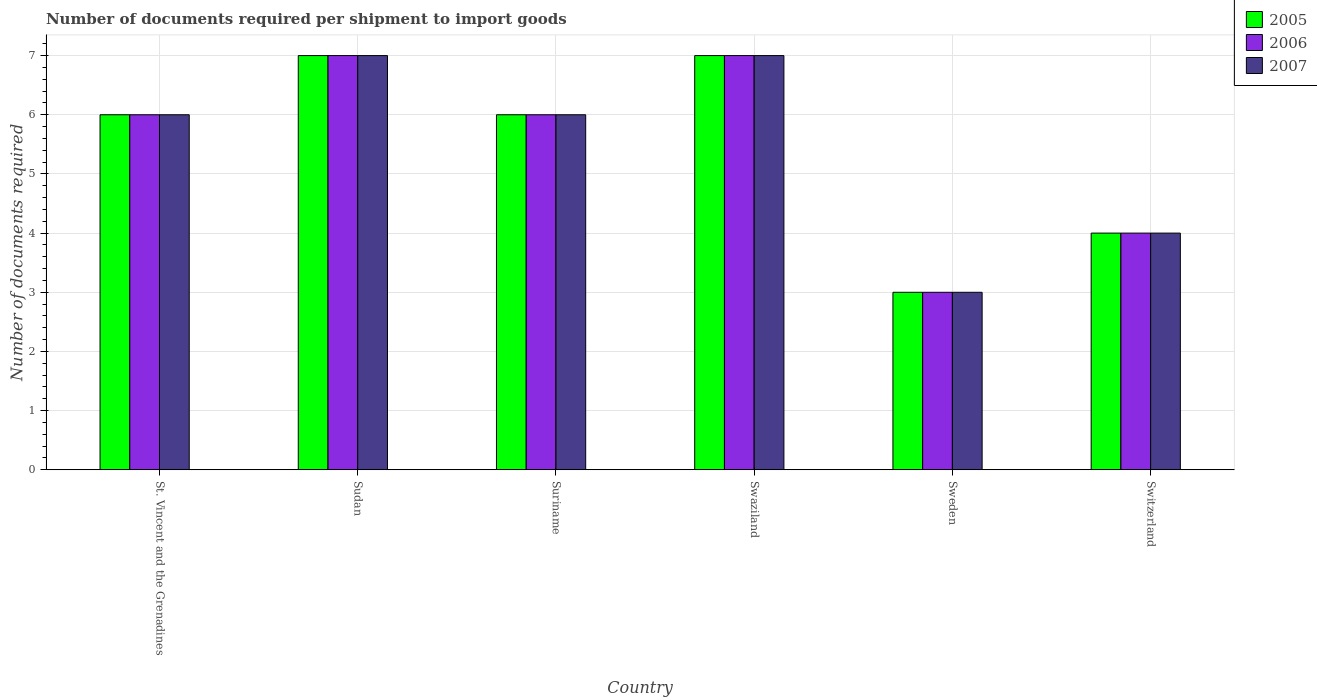Are the number of bars on each tick of the X-axis equal?
Keep it short and to the point. Yes. What is the label of the 4th group of bars from the left?
Keep it short and to the point. Swaziland. Across all countries, what is the maximum number of documents required per shipment to import goods in 2005?
Provide a succinct answer. 7. In which country was the number of documents required per shipment to import goods in 2006 maximum?
Provide a short and direct response. Sudan. What is the total number of documents required per shipment to import goods in 2006 in the graph?
Make the answer very short. 33. What is the difference between the number of documents required per shipment to import goods in 2006 in Switzerland and the number of documents required per shipment to import goods in 2007 in Swaziland?
Offer a terse response. -3. What is the difference between the number of documents required per shipment to import goods of/in 2005 and number of documents required per shipment to import goods of/in 2006 in Swaziland?
Your response must be concise. 0. In how many countries, is the number of documents required per shipment to import goods in 2007 greater than 5.2?
Offer a terse response. 4. What is the ratio of the number of documents required per shipment to import goods in 2007 in Sudan to that in Suriname?
Make the answer very short. 1.17. Is the number of documents required per shipment to import goods in 2006 in St. Vincent and the Grenadines less than that in Swaziland?
Offer a very short reply. Yes. Is the difference between the number of documents required per shipment to import goods in 2005 in Sudan and Suriname greater than the difference between the number of documents required per shipment to import goods in 2006 in Sudan and Suriname?
Your answer should be compact. No. What is the difference between the highest and the second highest number of documents required per shipment to import goods in 2005?
Offer a terse response. -1. In how many countries, is the number of documents required per shipment to import goods in 2007 greater than the average number of documents required per shipment to import goods in 2007 taken over all countries?
Offer a very short reply. 4. How many bars are there?
Make the answer very short. 18. Does the graph contain any zero values?
Give a very brief answer. No. Where does the legend appear in the graph?
Your answer should be compact. Top right. How many legend labels are there?
Ensure brevity in your answer.  3. How are the legend labels stacked?
Make the answer very short. Vertical. What is the title of the graph?
Ensure brevity in your answer.  Number of documents required per shipment to import goods. Does "2007" appear as one of the legend labels in the graph?
Ensure brevity in your answer.  Yes. What is the label or title of the Y-axis?
Your response must be concise. Number of documents required. What is the Number of documents required of 2006 in St. Vincent and the Grenadines?
Give a very brief answer. 6. What is the Number of documents required in 2005 in Sudan?
Offer a very short reply. 7. What is the Number of documents required in 2007 in Sudan?
Offer a very short reply. 7. What is the Number of documents required in 2005 in Suriname?
Your answer should be very brief. 6. What is the Number of documents required of 2006 in Suriname?
Your answer should be very brief. 6. What is the Number of documents required of 2006 in Swaziland?
Provide a short and direct response. 7. What is the Number of documents required of 2007 in Swaziland?
Your answer should be very brief. 7. What is the Number of documents required in 2007 in Switzerland?
Make the answer very short. 4. Across all countries, what is the minimum Number of documents required in 2005?
Make the answer very short. 3. Across all countries, what is the minimum Number of documents required in 2007?
Provide a succinct answer. 3. What is the total Number of documents required of 2006 in the graph?
Provide a succinct answer. 33. What is the difference between the Number of documents required of 2005 in St. Vincent and the Grenadines and that in Sudan?
Ensure brevity in your answer.  -1. What is the difference between the Number of documents required in 2005 in St. Vincent and the Grenadines and that in Suriname?
Your answer should be very brief. 0. What is the difference between the Number of documents required in 2006 in St. Vincent and the Grenadines and that in Suriname?
Offer a very short reply. 0. What is the difference between the Number of documents required in 2005 in St. Vincent and the Grenadines and that in Swaziland?
Offer a very short reply. -1. What is the difference between the Number of documents required in 2005 in St. Vincent and the Grenadines and that in Sweden?
Offer a very short reply. 3. What is the difference between the Number of documents required of 2006 in St. Vincent and the Grenadines and that in Switzerland?
Give a very brief answer. 2. What is the difference between the Number of documents required of 2006 in Sudan and that in Suriname?
Offer a terse response. 1. What is the difference between the Number of documents required of 2007 in Sudan and that in Suriname?
Offer a terse response. 1. What is the difference between the Number of documents required in 2005 in Sudan and that in Swaziland?
Give a very brief answer. 0. What is the difference between the Number of documents required in 2005 in Sudan and that in Sweden?
Provide a succinct answer. 4. What is the difference between the Number of documents required in 2007 in Sudan and that in Sweden?
Provide a succinct answer. 4. What is the difference between the Number of documents required of 2005 in Sudan and that in Switzerland?
Offer a very short reply. 3. What is the difference between the Number of documents required of 2005 in Suriname and that in Swaziland?
Ensure brevity in your answer.  -1. What is the difference between the Number of documents required in 2005 in Suriname and that in Sweden?
Offer a terse response. 3. What is the difference between the Number of documents required of 2005 in Suriname and that in Switzerland?
Keep it short and to the point. 2. What is the difference between the Number of documents required of 2007 in Swaziland and that in Sweden?
Your response must be concise. 4. What is the difference between the Number of documents required in 2005 in Sweden and that in Switzerland?
Your answer should be very brief. -1. What is the difference between the Number of documents required of 2006 in Sweden and that in Switzerland?
Your response must be concise. -1. What is the difference between the Number of documents required in 2007 in Sweden and that in Switzerland?
Your answer should be very brief. -1. What is the difference between the Number of documents required in 2005 in St. Vincent and the Grenadines and the Number of documents required in 2006 in Sudan?
Provide a short and direct response. -1. What is the difference between the Number of documents required in 2005 in St. Vincent and the Grenadines and the Number of documents required in 2007 in Sudan?
Offer a very short reply. -1. What is the difference between the Number of documents required of 2005 in St. Vincent and the Grenadines and the Number of documents required of 2006 in Suriname?
Your answer should be compact. 0. What is the difference between the Number of documents required of 2005 in St. Vincent and the Grenadines and the Number of documents required of 2007 in Swaziland?
Your answer should be very brief. -1. What is the difference between the Number of documents required of 2005 in St. Vincent and the Grenadines and the Number of documents required of 2006 in Sweden?
Make the answer very short. 3. What is the difference between the Number of documents required in 2005 in St. Vincent and the Grenadines and the Number of documents required in 2007 in Sweden?
Keep it short and to the point. 3. What is the difference between the Number of documents required in 2005 in St. Vincent and the Grenadines and the Number of documents required in 2006 in Switzerland?
Ensure brevity in your answer.  2. What is the difference between the Number of documents required in 2005 in Sudan and the Number of documents required in 2006 in Suriname?
Provide a succinct answer. 1. What is the difference between the Number of documents required of 2005 in Sudan and the Number of documents required of 2007 in Suriname?
Your response must be concise. 1. What is the difference between the Number of documents required in 2005 in Sudan and the Number of documents required in 2006 in Swaziland?
Give a very brief answer. 0. What is the difference between the Number of documents required of 2006 in Sudan and the Number of documents required of 2007 in Swaziland?
Offer a very short reply. 0. What is the difference between the Number of documents required in 2005 in Sudan and the Number of documents required in 2006 in Sweden?
Offer a very short reply. 4. What is the difference between the Number of documents required of 2005 in Sudan and the Number of documents required of 2007 in Switzerland?
Provide a short and direct response. 3. What is the difference between the Number of documents required in 2006 in Sudan and the Number of documents required in 2007 in Switzerland?
Make the answer very short. 3. What is the difference between the Number of documents required of 2005 in Suriname and the Number of documents required of 2006 in Swaziland?
Your answer should be very brief. -1. What is the difference between the Number of documents required of 2005 in Suriname and the Number of documents required of 2007 in Swaziland?
Your response must be concise. -1. What is the difference between the Number of documents required in 2006 in Suriname and the Number of documents required in 2007 in Swaziland?
Keep it short and to the point. -1. What is the difference between the Number of documents required in 2005 in Suriname and the Number of documents required in 2006 in Sweden?
Provide a succinct answer. 3. What is the difference between the Number of documents required of 2006 in Suriname and the Number of documents required of 2007 in Sweden?
Offer a very short reply. 3. What is the difference between the Number of documents required of 2005 in Suriname and the Number of documents required of 2006 in Switzerland?
Your answer should be very brief. 2. What is the difference between the Number of documents required in 2005 in Swaziland and the Number of documents required in 2007 in Sweden?
Make the answer very short. 4. What is the difference between the Number of documents required in 2006 in Swaziland and the Number of documents required in 2007 in Sweden?
Your answer should be very brief. 4. What is the difference between the Number of documents required in 2005 in Swaziland and the Number of documents required in 2007 in Switzerland?
Make the answer very short. 3. What is the difference between the Number of documents required of 2005 in Sweden and the Number of documents required of 2007 in Switzerland?
Provide a succinct answer. -1. What is the average Number of documents required of 2006 per country?
Ensure brevity in your answer.  5.5. What is the difference between the Number of documents required in 2005 and Number of documents required in 2006 in St. Vincent and the Grenadines?
Offer a very short reply. 0. What is the difference between the Number of documents required of 2006 and Number of documents required of 2007 in St. Vincent and the Grenadines?
Offer a very short reply. 0. What is the difference between the Number of documents required of 2006 and Number of documents required of 2007 in Sudan?
Provide a succinct answer. 0. What is the difference between the Number of documents required of 2005 and Number of documents required of 2006 in Suriname?
Give a very brief answer. 0. What is the difference between the Number of documents required in 2005 and Number of documents required in 2007 in Suriname?
Offer a very short reply. 0. What is the difference between the Number of documents required of 2005 and Number of documents required of 2006 in Swaziland?
Ensure brevity in your answer.  0. What is the difference between the Number of documents required of 2006 and Number of documents required of 2007 in Swaziland?
Provide a succinct answer. 0. What is the difference between the Number of documents required in 2005 and Number of documents required in 2006 in Sweden?
Your response must be concise. 0. What is the difference between the Number of documents required of 2005 and Number of documents required of 2006 in Switzerland?
Provide a succinct answer. 0. What is the difference between the Number of documents required of 2006 and Number of documents required of 2007 in Switzerland?
Keep it short and to the point. 0. What is the ratio of the Number of documents required of 2007 in St. Vincent and the Grenadines to that in Sudan?
Provide a short and direct response. 0.86. What is the ratio of the Number of documents required of 2005 in St. Vincent and the Grenadines to that in Suriname?
Offer a very short reply. 1. What is the ratio of the Number of documents required in 2006 in St. Vincent and the Grenadines to that in Suriname?
Provide a succinct answer. 1. What is the ratio of the Number of documents required in 2007 in St. Vincent and the Grenadines to that in Suriname?
Offer a terse response. 1. What is the ratio of the Number of documents required in 2006 in St. Vincent and the Grenadines to that in Swaziland?
Make the answer very short. 0.86. What is the ratio of the Number of documents required in 2005 in Sudan to that in Swaziland?
Ensure brevity in your answer.  1. What is the ratio of the Number of documents required of 2006 in Sudan to that in Swaziland?
Provide a succinct answer. 1. What is the ratio of the Number of documents required of 2007 in Sudan to that in Swaziland?
Your answer should be very brief. 1. What is the ratio of the Number of documents required of 2005 in Sudan to that in Sweden?
Make the answer very short. 2.33. What is the ratio of the Number of documents required of 2006 in Sudan to that in Sweden?
Your answer should be very brief. 2.33. What is the ratio of the Number of documents required of 2007 in Sudan to that in Sweden?
Your answer should be very brief. 2.33. What is the ratio of the Number of documents required of 2007 in Sudan to that in Switzerland?
Provide a succinct answer. 1.75. What is the ratio of the Number of documents required in 2007 in Suriname to that in Swaziland?
Offer a very short reply. 0.86. What is the ratio of the Number of documents required of 2005 in Suriname to that in Sweden?
Ensure brevity in your answer.  2. What is the ratio of the Number of documents required of 2006 in Suriname to that in Sweden?
Your answer should be very brief. 2. What is the ratio of the Number of documents required in 2007 in Suriname to that in Switzerland?
Offer a very short reply. 1.5. What is the ratio of the Number of documents required in 2005 in Swaziland to that in Sweden?
Provide a short and direct response. 2.33. What is the ratio of the Number of documents required of 2006 in Swaziland to that in Sweden?
Keep it short and to the point. 2.33. What is the ratio of the Number of documents required of 2007 in Swaziland to that in Sweden?
Give a very brief answer. 2.33. What is the ratio of the Number of documents required of 2007 in Swaziland to that in Switzerland?
Provide a short and direct response. 1.75. What is the ratio of the Number of documents required in 2007 in Sweden to that in Switzerland?
Keep it short and to the point. 0.75. What is the difference between the highest and the second highest Number of documents required of 2006?
Your response must be concise. 0. What is the difference between the highest and the second highest Number of documents required in 2007?
Make the answer very short. 0. What is the difference between the highest and the lowest Number of documents required of 2006?
Offer a very short reply. 4. 